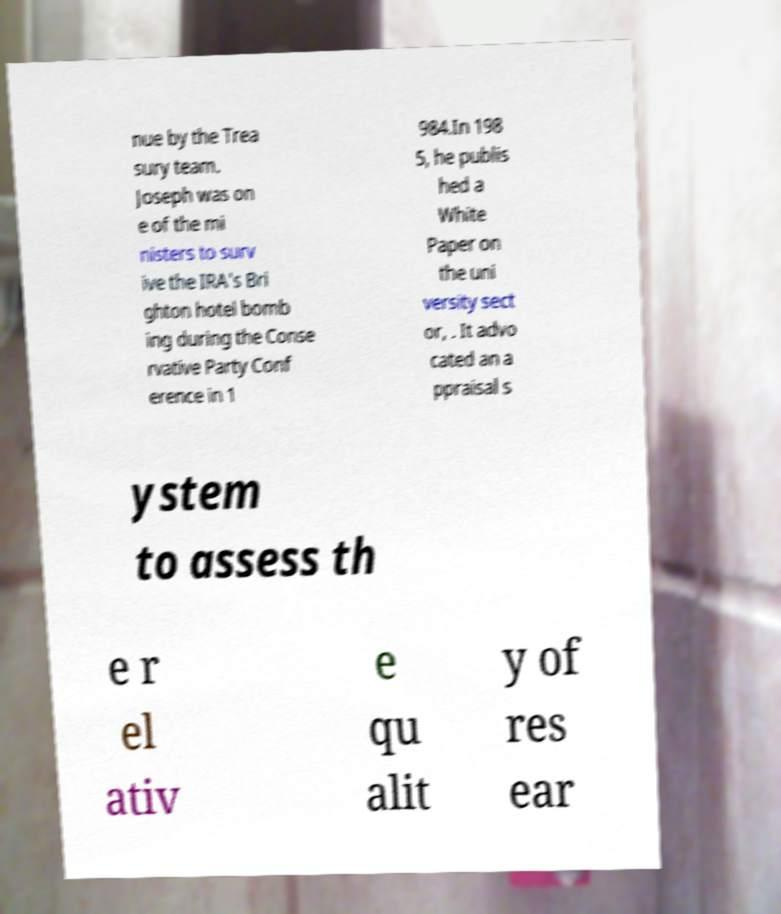Can you accurately transcribe the text from the provided image for me? nue by the Trea sury team. Joseph was on e of the mi nisters to surv ive the IRA's Bri ghton hotel bomb ing during the Conse rvative Party Conf erence in 1 984.In 198 5, he publis hed a White Paper on the uni versity sect or, . It advo cated an a ppraisal s ystem to assess th e r el ativ e qu alit y of res ear 